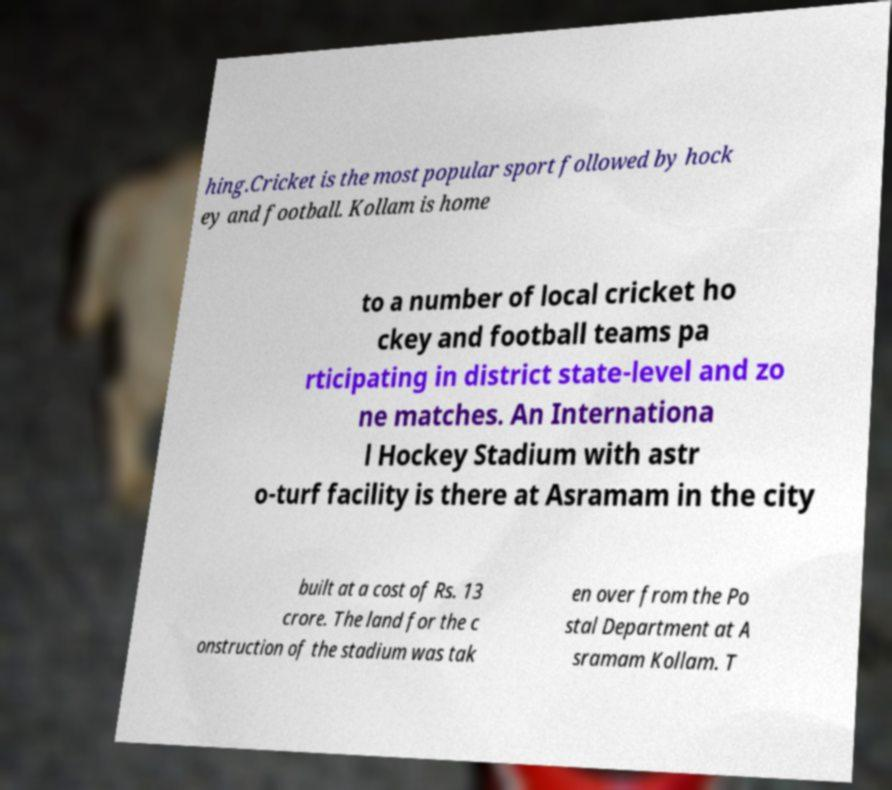There's text embedded in this image that I need extracted. Can you transcribe it verbatim? hing.Cricket is the most popular sport followed by hock ey and football. Kollam is home to a number of local cricket ho ckey and football teams pa rticipating in district state-level and zo ne matches. An Internationa l Hockey Stadium with astr o-turf facility is there at Asramam in the city built at a cost of Rs. 13 crore. The land for the c onstruction of the stadium was tak en over from the Po stal Department at A sramam Kollam. T 